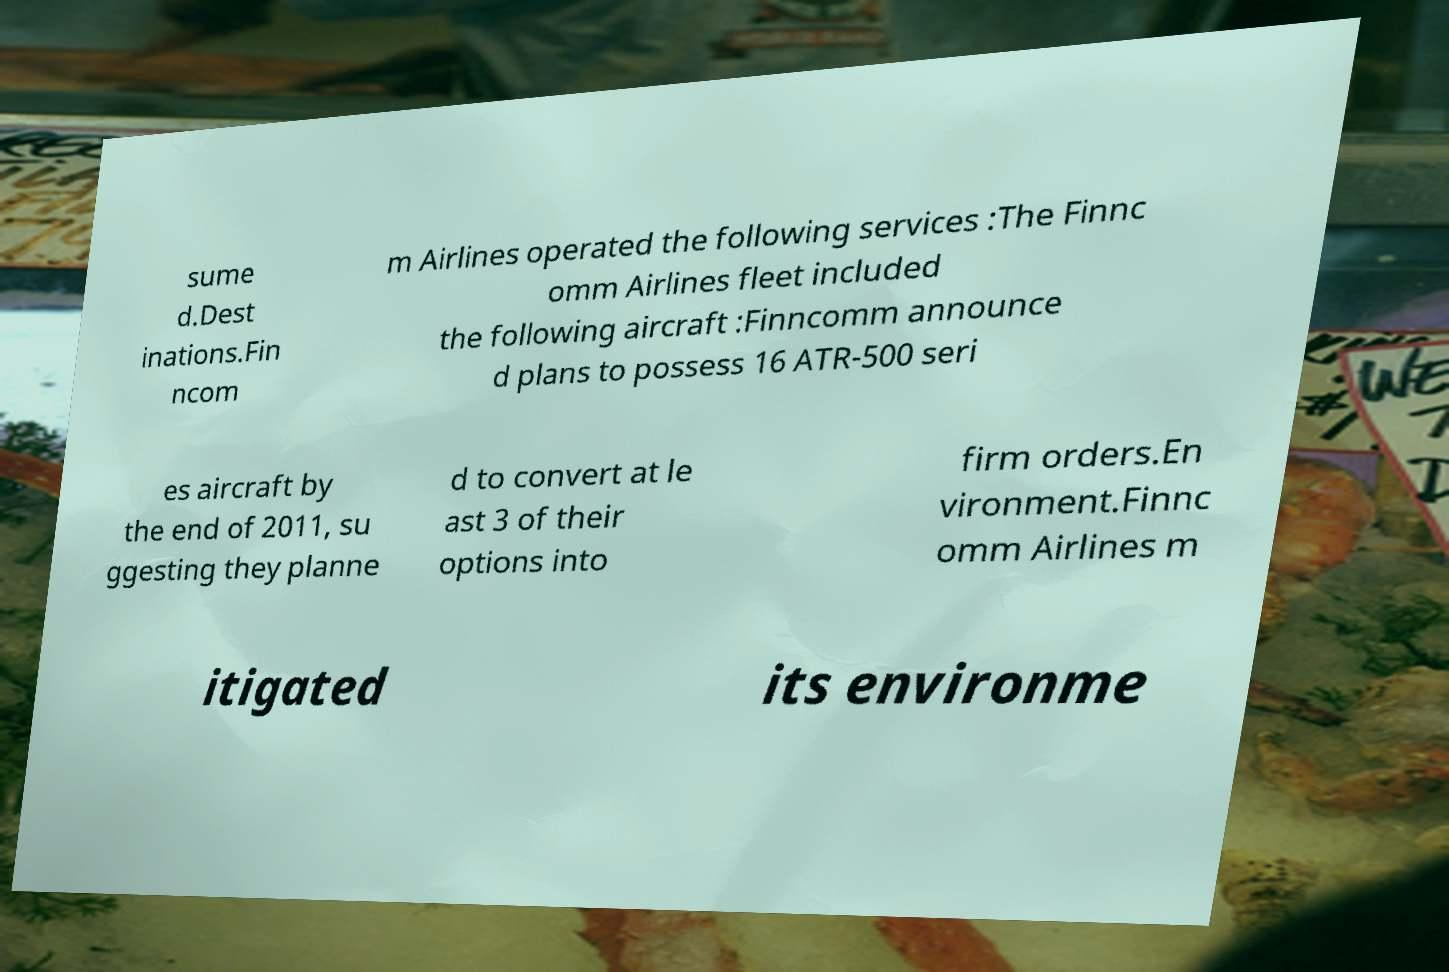Can you accurately transcribe the text from the provided image for me? sume d.Dest inations.Fin ncom m Airlines operated the following services :The Finnc omm Airlines fleet included the following aircraft :Finncomm announce d plans to possess 16 ATR-500 seri es aircraft by the end of 2011, su ggesting they planne d to convert at le ast 3 of their options into firm orders.En vironment.Finnc omm Airlines m itigated its environme 